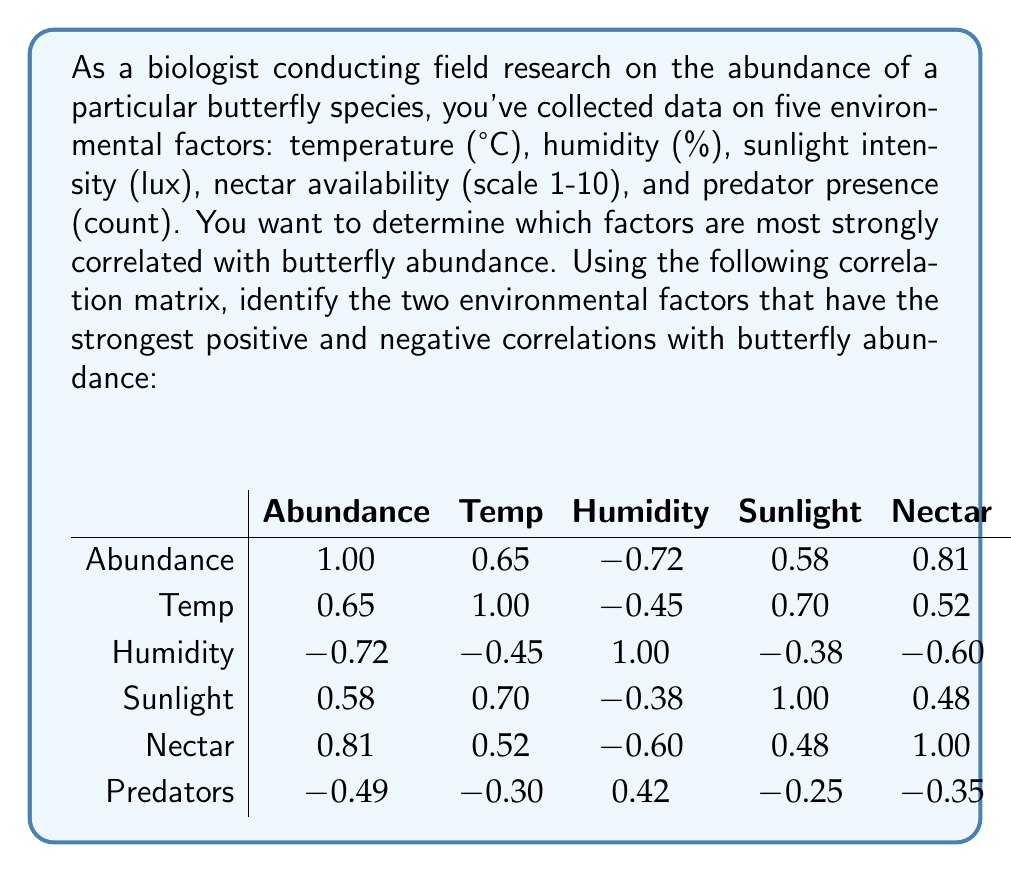Provide a solution to this math problem. To solve this problem, we need to examine the correlation coefficients between butterfly abundance and each environmental factor. The correlation matrix provides these coefficients in the first row (or column) of the matrix.

1. First, let's identify the correlation coefficients for each factor with abundance:
   - Temperature: 0.65
   - Humidity: -0.72
   - Sunlight: 0.58
   - Nectar availability: 0.81
   - Predator presence: -0.49

2. To find the strongest positive correlation, we look for the largest positive value:
   - The largest positive value is 0.81, corresponding to nectar availability.

3. To find the strongest negative correlation, we look for the largest negative value (closest to -1):
   - The largest negative value is -0.72, corresponding to humidity.

4. It's important to note that correlation coefficients range from -1 to 1, where:
   - 1 indicates a perfect positive correlation
   - -1 indicates a perfect negative correlation
   - 0 indicates no correlation

5. In this case, nectar availability (0.81) shows a strong positive correlation with butterfly abundance, suggesting that as nectar availability increases, butterfly abundance tends to increase.

6. Humidity (-0.72) shows a strong negative correlation with butterfly abundance, suggesting that as humidity increases, butterfly abundance tends to decrease.
Answer: The two environmental factors with the strongest correlations to butterfly abundance are:
1. Strongest positive correlation: Nectar availability (0.81)
2. Strongest negative correlation: Humidity (-0.72) 